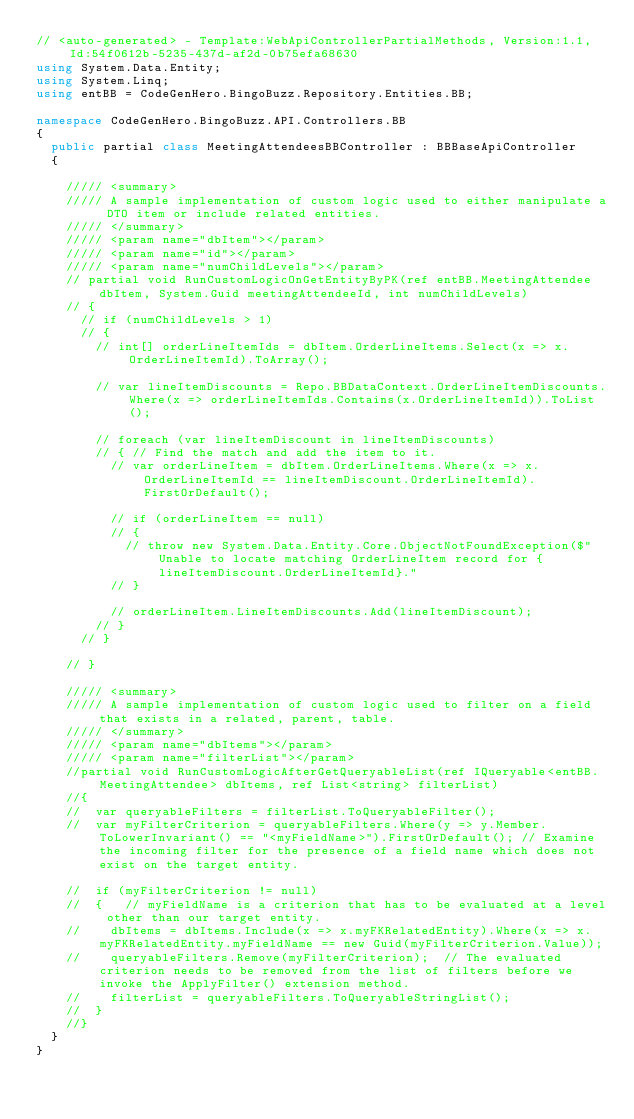Convert code to text. <code><loc_0><loc_0><loc_500><loc_500><_C#_>// <auto-generated> - Template:WebApiControllerPartialMethods, Version:1.1, Id:54f0612b-5235-437d-af2d-0b75efa68630
using System.Data.Entity;
using System.Linq;
using entBB = CodeGenHero.BingoBuzz.Repository.Entities.BB;

namespace CodeGenHero.BingoBuzz.API.Controllers.BB
{
	public partial class MeetingAttendeesBBController : BBBaseApiController
	{

		///// <summary>
		///// A sample implementation of custom logic used to either manipulate a DTO item or include related entities.
		///// </summary>
		///// <param name="dbItem"></param>
		///// <param name="id"></param>
		///// <param name="numChildLevels"></param>
		// partial void RunCustomLogicOnGetEntityByPK(ref entBB.MeetingAttendee dbItem, System.Guid meetingAttendeeId, int numChildLevels)
		// {
			// if (numChildLevels > 1)
			// {
				// int[] orderLineItemIds = dbItem.OrderLineItems.Select(x => x.OrderLineItemId).ToArray();

				// var lineItemDiscounts = Repo.BBDataContext.OrderLineItemDiscounts.Where(x => orderLineItemIds.Contains(x.OrderLineItemId)).ToList();

				// foreach (var lineItemDiscount in lineItemDiscounts)
				// { // Find the match and add the item to it.
					// var orderLineItem = dbItem.OrderLineItems.Where(x => x.OrderLineItemId == lineItemDiscount.OrderLineItemId).FirstOrDefault();

					// if (orderLineItem == null)
					// {
						// throw new System.Data.Entity.Core.ObjectNotFoundException($"Unable to locate matching OrderLineItem record for {lineItemDiscount.OrderLineItemId}."
					// }

					// orderLineItem.LineItemDiscounts.Add(lineItemDiscount);
				// }
			// }

		// }

		///// <summary>
		///// A sample implementation of custom logic used to filter on a field that exists in a related, parent, table.
		///// </summary>
		///// <param name="dbItems"></param>
		///// <param name="filterList"></param>
		//partial void RunCustomLogicAfterGetQueryableList(ref IQueryable<entBB.MeetingAttendee> dbItems, ref List<string> filterList)
		//{
		//	var queryableFilters = filterList.ToQueryableFilter();
		//	var myFilterCriterion = queryableFilters.Where(y => y.Member.ToLowerInvariant() == "<myFieldName>").FirstOrDefault(); // Examine the incoming filter for the presence of a field name which does not exist on the target entity.

		//	if (myFilterCriterion != null)
		//	{   // myFieldName is a criterion that has to be evaluated at a level other than our target entity.
		//		dbItems = dbItems.Include(x => x.myFKRelatedEntity).Where(x => x.myFKRelatedEntity.myFieldName == new Guid(myFilterCriterion.Value));
		//		queryableFilters.Remove(myFilterCriterion);  // The evaluated criterion needs to be removed from the list of filters before we invoke the ApplyFilter() extension method.
		//		filterList = queryableFilters.ToQueryableStringList();
		//	}
		//}
	}
}
</code> 